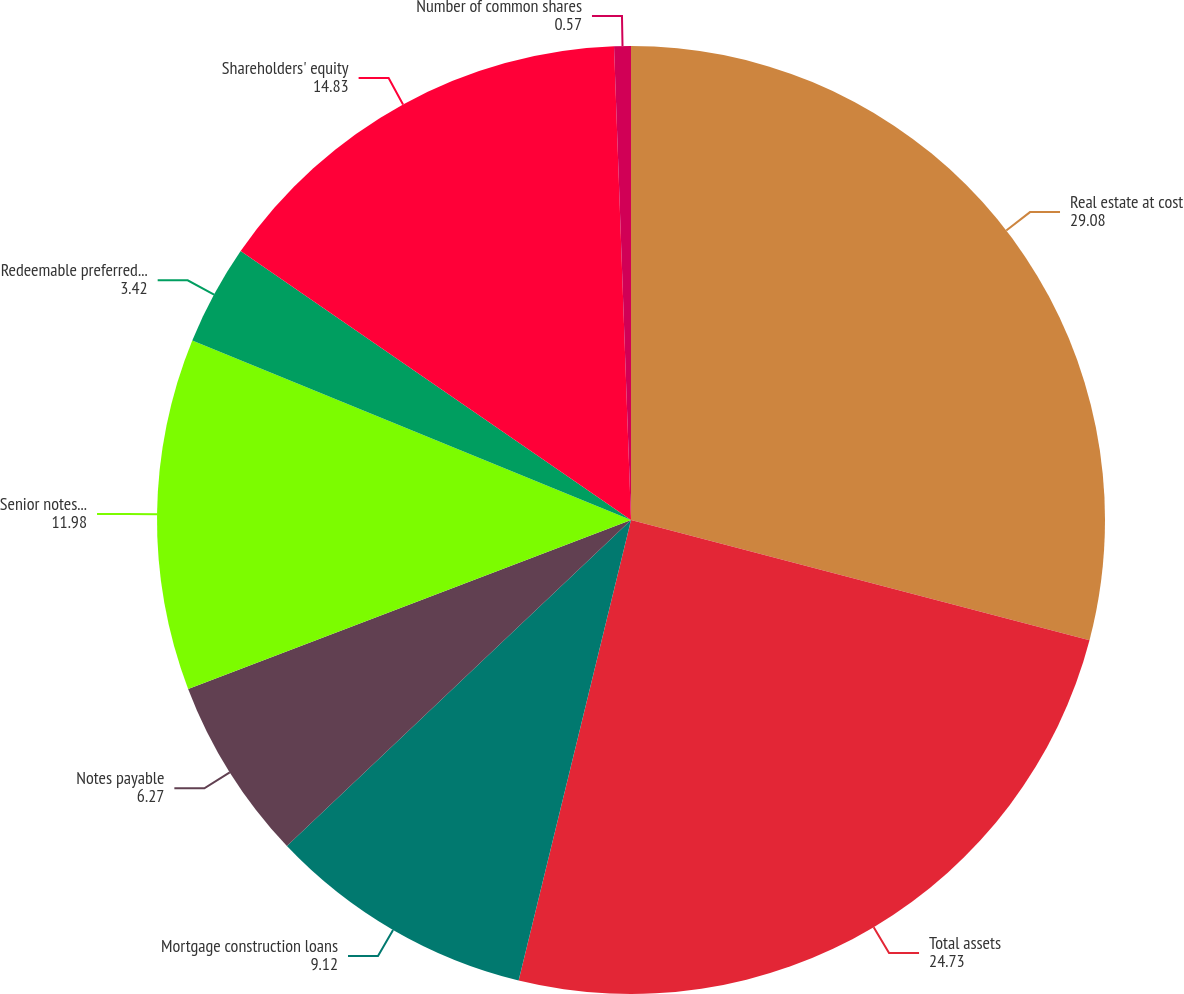Convert chart to OTSL. <chart><loc_0><loc_0><loc_500><loc_500><pie_chart><fcel>Real estate at cost<fcel>Total assets<fcel>Mortgage construction loans<fcel>Notes payable<fcel>Senior notes and debentures<fcel>Redeemable preferred shares<fcel>Shareholders' equity<fcel>Number of common shares<nl><fcel>29.08%<fcel>24.73%<fcel>9.12%<fcel>6.27%<fcel>11.98%<fcel>3.42%<fcel>14.83%<fcel>0.57%<nl></chart> 